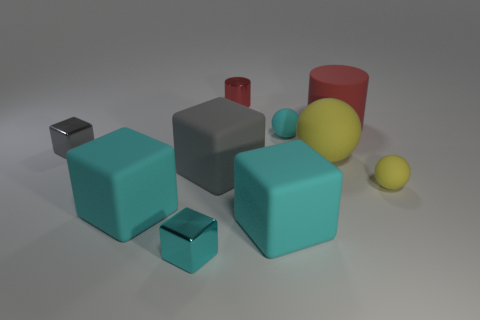What number of other objects are the same shape as the tiny cyan shiny object?
Make the answer very short. 4. There is a tiny red shiny object on the right side of the large gray matte cube; is there a red object that is right of it?
Provide a short and direct response. Yes. Is there a tiny gray cube that has the same material as the cyan ball?
Offer a terse response. No. What material is the big yellow sphere that is right of the small cube in front of the tiny gray metal block?
Keep it short and to the point. Rubber. What is the material of the big object that is on the right side of the tiny cyan rubber sphere and in front of the large matte cylinder?
Ensure brevity in your answer.  Rubber. Are there the same number of small cyan metallic objects left of the tiny gray metallic thing and gray blocks?
Provide a short and direct response. No. How many cyan objects are the same shape as the big yellow object?
Ensure brevity in your answer.  1. There is a red cylinder on the right side of the yellow rubber thing that is on the left side of the tiny rubber thing that is in front of the small cyan rubber sphere; what is its size?
Provide a short and direct response. Large. Are the small cyan thing that is in front of the small yellow rubber sphere and the cyan ball made of the same material?
Provide a short and direct response. No. Is the number of matte things that are behind the small yellow rubber sphere the same as the number of small cubes that are behind the big red rubber object?
Provide a succinct answer. No. 